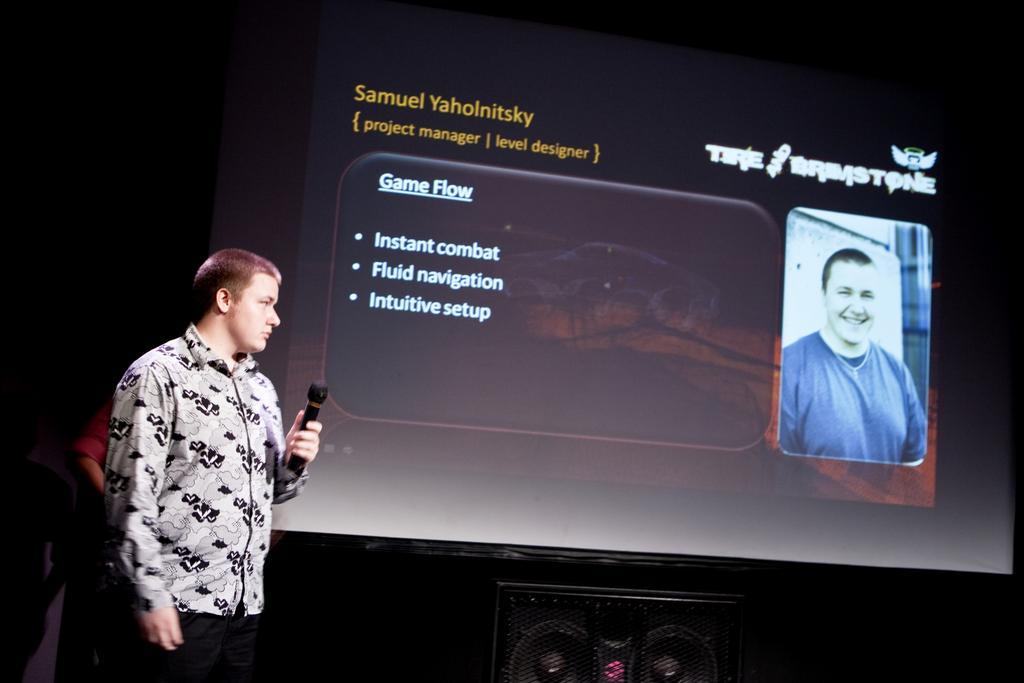Describe this image in one or two sentences. This man is standing in-front of this screen. On this screen there is a photo of a person. This man is holding a guitar. Under this screen there is a speaker. 